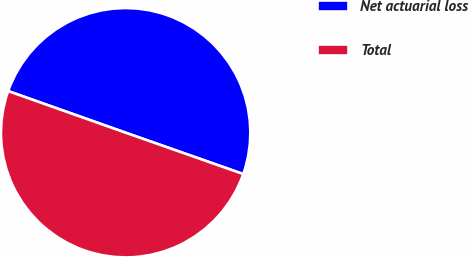Convert chart. <chart><loc_0><loc_0><loc_500><loc_500><pie_chart><fcel>Net actuarial loss<fcel>Total<nl><fcel>49.96%<fcel>50.04%<nl></chart> 